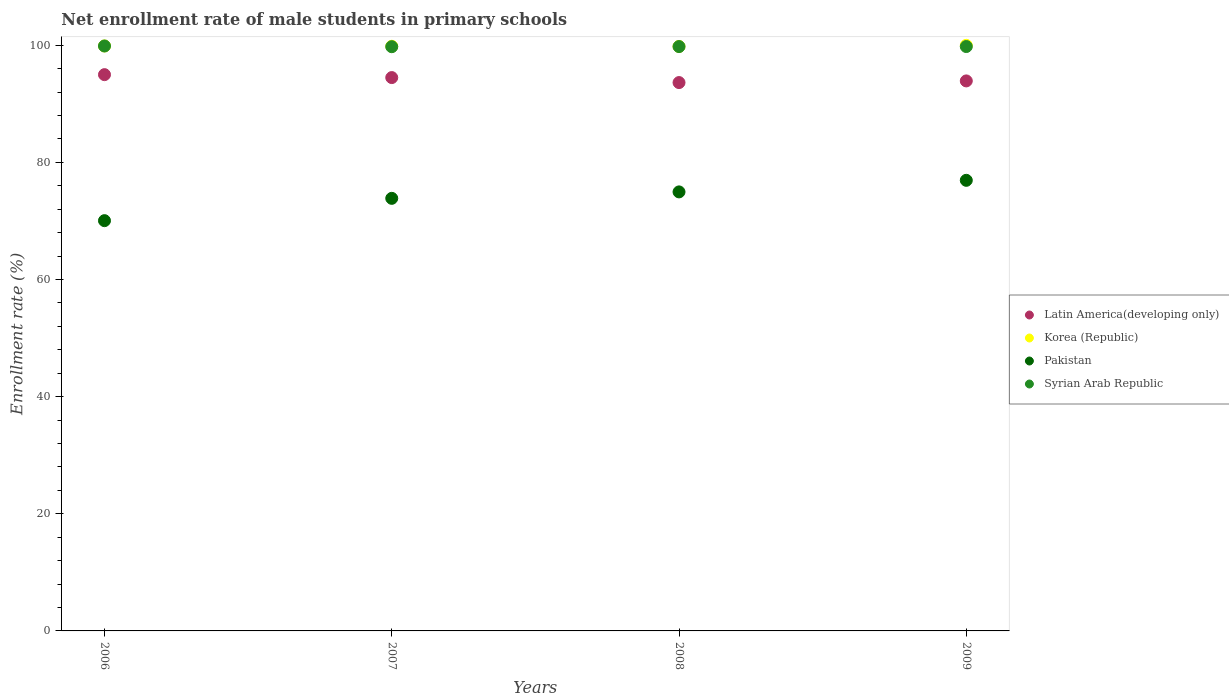How many different coloured dotlines are there?
Your answer should be compact. 4. Is the number of dotlines equal to the number of legend labels?
Make the answer very short. Yes. What is the net enrollment rate of male students in primary schools in Syrian Arab Republic in 2006?
Your answer should be compact. 99.86. Across all years, what is the maximum net enrollment rate of male students in primary schools in Syrian Arab Republic?
Offer a terse response. 99.86. Across all years, what is the minimum net enrollment rate of male students in primary schools in Latin America(developing only)?
Provide a succinct answer. 93.62. In which year was the net enrollment rate of male students in primary schools in Pakistan minimum?
Ensure brevity in your answer.  2006. What is the total net enrollment rate of male students in primary schools in Latin America(developing only) in the graph?
Offer a very short reply. 376.95. What is the difference between the net enrollment rate of male students in primary schools in Pakistan in 2006 and that in 2007?
Provide a succinct answer. -3.81. What is the difference between the net enrollment rate of male students in primary schools in Pakistan in 2006 and the net enrollment rate of male students in primary schools in Syrian Arab Republic in 2009?
Your answer should be compact. -29.73. What is the average net enrollment rate of male students in primary schools in Pakistan per year?
Provide a short and direct response. 73.94. In the year 2006, what is the difference between the net enrollment rate of male students in primary schools in Latin America(developing only) and net enrollment rate of male students in primary schools in Pakistan?
Ensure brevity in your answer.  24.93. In how many years, is the net enrollment rate of male students in primary schools in Korea (Republic) greater than 52 %?
Your answer should be compact. 4. What is the ratio of the net enrollment rate of male students in primary schools in Latin America(developing only) in 2006 to that in 2009?
Keep it short and to the point. 1.01. Is the net enrollment rate of male students in primary schools in Syrian Arab Republic in 2008 less than that in 2009?
Your answer should be compact. Yes. What is the difference between the highest and the second highest net enrollment rate of male students in primary schools in Syrian Arab Republic?
Provide a short and direct response. 0.09. What is the difference between the highest and the lowest net enrollment rate of male students in primary schools in Latin America(developing only)?
Your response must be concise. 1.35. Is the sum of the net enrollment rate of male students in primary schools in Syrian Arab Republic in 2007 and 2009 greater than the maximum net enrollment rate of male students in primary schools in Pakistan across all years?
Make the answer very short. Yes. Is it the case that in every year, the sum of the net enrollment rate of male students in primary schools in Latin America(developing only) and net enrollment rate of male students in primary schools in Pakistan  is greater than the net enrollment rate of male students in primary schools in Syrian Arab Republic?
Ensure brevity in your answer.  Yes. How many years are there in the graph?
Offer a very short reply. 4. What is the difference between two consecutive major ticks on the Y-axis?
Ensure brevity in your answer.  20. Are the values on the major ticks of Y-axis written in scientific E-notation?
Ensure brevity in your answer.  No. Does the graph contain any zero values?
Your answer should be very brief. No. Where does the legend appear in the graph?
Keep it short and to the point. Center right. How many legend labels are there?
Give a very brief answer. 4. How are the legend labels stacked?
Give a very brief answer. Vertical. What is the title of the graph?
Give a very brief answer. Net enrollment rate of male students in primary schools. Does "Niger" appear as one of the legend labels in the graph?
Provide a succinct answer. No. What is the label or title of the Y-axis?
Provide a short and direct response. Enrollment rate (%). What is the Enrollment rate (%) of Latin America(developing only) in 2006?
Your answer should be compact. 94.97. What is the Enrollment rate (%) in Korea (Republic) in 2006?
Your answer should be compact. 99.87. What is the Enrollment rate (%) in Pakistan in 2006?
Offer a very short reply. 70.04. What is the Enrollment rate (%) in Syrian Arab Republic in 2006?
Your answer should be very brief. 99.86. What is the Enrollment rate (%) of Latin America(developing only) in 2007?
Your answer should be very brief. 94.47. What is the Enrollment rate (%) of Korea (Republic) in 2007?
Offer a very short reply. 99.81. What is the Enrollment rate (%) of Pakistan in 2007?
Your answer should be very brief. 73.85. What is the Enrollment rate (%) of Syrian Arab Republic in 2007?
Provide a short and direct response. 99.74. What is the Enrollment rate (%) of Latin America(developing only) in 2008?
Your answer should be very brief. 93.62. What is the Enrollment rate (%) of Korea (Republic) in 2008?
Provide a succinct answer. 99.78. What is the Enrollment rate (%) of Pakistan in 2008?
Make the answer very short. 74.95. What is the Enrollment rate (%) in Syrian Arab Republic in 2008?
Keep it short and to the point. 99.76. What is the Enrollment rate (%) of Latin America(developing only) in 2009?
Make the answer very short. 93.9. What is the Enrollment rate (%) of Korea (Republic) in 2009?
Your answer should be compact. 99.97. What is the Enrollment rate (%) of Pakistan in 2009?
Provide a short and direct response. 76.93. What is the Enrollment rate (%) of Syrian Arab Republic in 2009?
Provide a short and direct response. 99.77. Across all years, what is the maximum Enrollment rate (%) in Latin America(developing only)?
Your answer should be compact. 94.97. Across all years, what is the maximum Enrollment rate (%) in Korea (Republic)?
Keep it short and to the point. 99.97. Across all years, what is the maximum Enrollment rate (%) of Pakistan?
Keep it short and to the point. 76.93. Across all years, what is the maximum Enrollment rate (%) of Syrian Arab Republic?
Your answer should be very brief. 99.86. Across all years, what is the minimum Enrollment rate (%) in Latin America(developing only)?
Your answer should be very brief. 93.62. Across all years, what is the minimum Enrollment rate (%) in Korea (Republic)?
Your answer should be compact. 99.78. Across all years, what is the minimum Enrollment rate (%) of Pakistan?
Offer a very short reply. 70.04. Across all years, what is the minimum Enrollment rate (%) in Syrian Arab Republic?
Make the answer very short. 99.74. What is the total Enrollment rate (%) in Latin America(developing only) in the graph?
Provide a short and direct response. 376.95. What is the total Enrollment rate (%) in Korea (Republic) in the graph?
Give a very brief answer. 399.44. What is the total Enrollment rate (%) of Pakistan in the graph?
Keep it short and to the point. 295.77. What is the total Enrollment rate (%) of Syrian Arab Republic in the graph?
Offer a very short reply. 399.13. What is the difference between the Enrollment rate (%) of Latin America(developing only) in 2006 and that in 2007?
Give a very brief answer. 0.5. What is the difference between the Enrollment rate (%) of Korea (Republic) in 2006 and that in 2007?
Provide a succinct answer. 0.05. What is the difference between the Enrollment rate (%) of Pakistan in 2006 and that in 2007?
Provide a short and direct response. -3.81. What is the difference between the Enrollment rate (%) of Syrian Arab Republic in 2006 and that in 2007?
Offer a very short reply. 0.12. What is the difference between the Enrollment rate (%) in Latin America(developing only) in 2006 and that in 2008?
Offer a terse response. 1.35. What is the difference between the Enrollment rate (%) of Korea (Republic) in 2006 and that in 2008?
Your response must be concise. 0.08. What is the difference between the Enrollment rate (%) of Pakistan in 2006 and that in 2008?
Ensure brevity in your answer.  -4.91. What is the difference between the Enrollment rate (%) in Syrian Arab Republic in 2006 and that in 2008?
Your answer should be compact. 0.1. What is the difference between the Enrollment rate (%) of Latin America(developing only) in 2006 and that in 2009?
Your answer should be compact. 1.07. What is the difference between the Enrollment rate (%) in Korea (Republic) in 2006 and that in 2009?
Ensure brevity in your answer.  -0.11. What is the difference between the Enrollment rate (%) of Pakistan in 2006 and that in 2009?
Provide a succinct answer. -6.89. What is the difference between the Enrollment rate (%) of Syrian Arab Republic in 2006 and that in 2009?
Your response must be concise. 0.09. What is the difference between the Enrollment rate (%) of Latin America(developing only) in 2007 and that in 2008?
Your response must be concise. 0.85. What is the difference between the Enrollment rate (%) of Korea (Republic) in 2007 and that in 2008?
Provide a succinct answer. 0.03. What is the difference between the Enrollment rate (%) of Pakistan in 2007 and that in 2008?
Your answer should be very brief. -1.1. What is the difference between the Enrollment rate (%) in Syrian Arab Republic in 2007 and that in 2008?
Keep it short and to the point. -0.02. What is the difference between the Enrollment rate (%) in Latin America(developing only) in 2007 and that in 2009?
Give a very brief answer. 0.57. What is the difference between the Enrollment rate (%) of Korea (Republic) in 2007 and that in 2009?
Offer a very short reply. -0.16. What is the difference between the Enrollment rate (%) of Pakistan in 2007 and that in 2009?
Your answer should be compact. -3.08. What is the difference between the Enrollment rate (%) of Syrian Arab Republic in 2007 and that in 2009?
Provide a succinct answer. -0.03. What is the difference between the Enrollment rate (%) in Latin America(developing only) in 2008 and that in 2009?
Provide a short and direct response. -0.28. What is the difference between the Enrollment rate (%) in Korea (Republic) in 2008 and that in 2009?
Provide a short and direct response. -0.19. What is the difference between the Enrollment rate (%) in Pakistan in 2008 and that in 2009?
Provide a short and direct response. -1.98. What is the difference between the Enrollment rate (%) of Syrian Arab Republic in 2008 and that in 2009?
Provide a succinct answer. -0. What is the difference between the Enrollment rate (%) of Latin America(developing only) in 2006 and the Enrollment rate (%) of Korea (Republic) in 2007?
Give a very brief answer. -4.84. What is the difference between the Enrollment rate (%) in Latin America(developing only) in 2006 and the Enrollment rate (%) in Pakistan in 2007?
Provide a short and direct response. 21.12. What is the difference between the Enrollment rate (%) of Latin America(developing only) in 2006 and the Enrollment rate (%) of Syrian Arab Republic in 2007?
Your answer should be compact. -4.77. What is the difference between the Enrollment rate (%) of Korea (Republic) in 2006 and the Enrollment rate (%) of Pakistan in 2007?
Make the answer very short. 26.01. What is the difference between the Enrollment rate (%) of Korea (Republic) in 2006 and the Enrollment rate (%) of Syrian Arab Republic in 2007?
Keep it short and to the point. 0.13. What is the difference between the Enrollment rate (%) in Pakistan in 2006 and the Enrollment rate (%) in Syrian Arab Republic in 2007?
Offer a very short reply. -29.7. What is the difference between the Enrollment rate (%) in Latin America(developing only) in 2006 and the Enrollment rate (%) in Korea (Republic) in 2008?
Your answer should be very brief. -4.82. What is the difference between the Enrollment rate (%) of Latin America(developing only) in 2006 and the Enrollment rate (%) of Pakistan in 2008?
Your answer should be compact. 20.02. What is the difference between the Enrollment rate (%) of Latin America(developing only) in 2006 and the Enrollment rate (%) of Syrian Arab Republic in 2008?
Provide a succinct answer. -4.79. What is the difference between the Enrollment rate (%) of Korea (Republic) in 2006 and the Enrollment rate (%) of Pakistan in 2008?
Your answer should be compact. 24.91. What is the difference between the Enrollment rate (%) of Korea (Republic) in 2006 and the Enrollment rate (%) of Syrian Arab Republic in 2008?
Your response must be concise. 0.1. What is the difference between the Enrollment rate (%) in Pakistan in 2006 and the Enrollment rate (%) in Syrian Arab Republic in 2008?
Your answer should be very brief. -29.72. What is the difference between the Enrollment rate (%) in Latin America(developing only) in 2006 and the Enrollment rate (%) in Korea (Republic) in 2009?
Your response must be concise. -5. What is the difference between the Enrollment rate (%) in Latin America(developing only) in 2006 and the Enrollment rate (%) in Pakistan in 2009?
Offer a very short reply. 18.04. What is the difference between the Enrollment rate (%) in Latin America(developing only) in 2006 and the Enrollment rate (%) in Syrian Arab Republic in 2009?
Give a very brief answer. -4.8. What is the difference between the Enrollment rate (%) of Korea (Republic) in 2006 and the Enrollment rate (%) of Pakistan in 2009?
Provide a succinct answer. 22.94. What is the difference between the Enrollment rate (%) in Korea (Republic) in 2006 and the Enrollment rate (%) in Syrian Arab Republic in 2009?
Provide a succinct answer. 0.1. What is the difference between the Enrollment rate (%) in Pakistan in 2006 and the Enrollment rate (%) in Syrian Arab Republic in 2009?
Keep it short and to the point. -29.73. What is the difference between the Enrollment rate (%) of Latin America(developing only) in 2007 and the Enrollment rate (%) of Korea (Republic) in 2008?
Offer a terse response. -5.32. What is the difference between the Enrollment rate (%) in Latin America(developing only) in 2007 and the Enrollment rate (%) in Pakistan in 2008?
Offer a very short reply. 19.52. What is the difference between the Enrollment rate (%) in Latin America(developing only) in 2007 and the Enrollment rate (%) in Syrian Arab Republic in 2008?
Your answer should be very brief. -5.29. What is the difference between the Enrollment rate (%) of Korea (Republic) in 2007 and the Enrollment rate (%) of Pakistan in 2008?
Offer a terse response. 24.86. What is the difference between the Enrollment rate (%) in Korea (Republic) in 2007 and the Enrollment rate (%) in Syrian Arab Republic in 2008?
Offer a terse response. 0.05. What is the difference between the Enrollment rate (%) in Pakistan in 2007 and the Enrollment rate (%) in Syrian Arab Republic in 2008?
Your answer should be very brief. -25.91. What is the difference between the Enrollment rate (%) of Latin America(developing only) in 2007 and the Enrollment rate (%) of Korea (Republic) in 2009?
Provide a succinct answer. -5.5. What is the difference between the Enrollment rate (%) in Latin America(developing only) in 2007 and the Enrollment rate (%) in Pakistan in 2009?
Ensure brevity in your answer.  17.54. What is the difference between the Enrollment rate (%) of Latin America(developing only) in 2007 and the Enrollment rate (%) of Syrian Arab Republic in 2009?
Your answer should be very brief. -5.3. What is the difference between the Enrollment rate (%) in Korea (Republic) in 2007 and the Enrollment rate (%) in Pakistan in 2009?
Ensure brevity in your answer.  22.89. What is the difference between the Enrollment rate (%) of Korea (Republic) in 2007 and the Enrollment rate (%) of Syrian Arab Republic in 2009?
Ensure brevity in your answer.  0.05. What is the difference between the Enrollment rate (%) in Pakistan in 2007 and the Enrollment rate (%) in Syrian Arab Republic in 2009?
Ensure brevity in your answer.  -25.92. What is the difference between the Enrollment rate (%) in Latin America(developing only) in 2008 and the Enrollment rate (%) in Korea (Republic) in 2009?
Keep it short and to the point. -6.36. What is the difference between the Enrollment rate (%) of Latin America(developing only) in 2008 and the Enrollment rate (%) of Pakistan in 2009?
Your answer should be compact. 16.69. What is the difference between the Enrollment rate (%) of Latin America(developing only) in 2008 and the Enrollment rate (%) of Syrian Arab Republic in 2009?
Provide a succinct answer. -6.15. What is the difference between the Enrollment rate (%) in Korea (Republic) in 2008 and the Enrollment rate (%) in Pakistan in 2009?
Offer a very short reply. 22.86. What is the difference between the Enrollment rate (%) in Korea (Republic) in 2008 and the Enrollment rate (%) in Syrian Arab Republic in 2009?
Provide a succinct answer. 0.02. What is the difference between the Enrollment rate (%) in Pakistan in 2008 and the Enrollment rate (%) in Syrian Arab Republic in 2009?
Keep it short and to the point. -24.82. What is the average Enrollment rate (%) of Latin America(developing only) per year?
Your answer should be compact. 94.24. What is the average Enrollment rate (%) in Korea (Republic) per year?
Offer a terse response. 99.86. What is the average Enrollment rate (%) of Pakistan per year?
Give a very brief answer. 73.94. What is the average Enrollment rate (%) in Syrian Arab Republic per year?
Your response must be concise. 99.78. In the year 2006, what is the difference between the Enrollment rate (%) in Latin America(developing only) and Enrollment rate (%) in Korea (Republic)?
Offer a very short reply. -4.9. In the year 2006, what is the difference between the Enrollment rate (%) in Latin America(developing only) and Enrollment rate (%) in Pakistan?
Ensure brevity in your answer.  24.93. In the year 2006, what is the difference between the Enrollment rate (%) of Latin America(developing only) and Enrollment rate (%) of Syrian Arab Republic?
Make the answer very short. -4.89. In the year 2006, what is the difference between the Enrollment rate (%) of Korea (Republic) and Enrollment rate (%) of Pakistan?
Your answer should be compact. 29.82. In the year 2006, what is the difference between the Enrollment rate (%) of Korea (Republic) and Enrollment rate (%) of Syrian Arab Republic?
Ensure brevity in your answer.  0.01. In the year 2006, what is the difference between the Enrollment rate (%) of Pakistan and Enrollment rate (%) of Syrian Arab Republic?
Your response must be concise. -29.82. In the year 2007, what is the difference between the Enrollment rate (%) of Latin America(developing only) and Enrollment rate (%) of Korea (Republic)?
Keep it short and to the point. -5.34. In the year 2007, what is the difference between the Enrollment rate (%) in Latin America(developing only) and Enrollment rate (%) in Pakistan?
Provide a succinct answer. 20.62. In the year 2007, what is the difference between the Enrollment rate (%) of Latin America(developing only) and Enrollment rate (%) of Syrian Arab Republic?
Ensure brevity in your answer.  -5.27. In the year 2007, what is the difference between the Enrollment rate (%) in Korea (Republic) and Enrollment rate (%) in Pakistan?
Offer a very short reply. 25.96. In the year 2007, what is the difference between the Enrollment rate (%) in Korea (Republic) and Enrollment rate (%) in Syrian Arab Republic?
Provide a short and direct response. 0.07. In the year 2007, what is the difference between the Enrollment rate (%) of Pakistan and Enrollment rate (%) of Syrian Arab Republic?
Ensure brevity in your answer.  -25.89. In the year 2008, what is the difference between the Enrollment rate (%) in Latin America(developing only) and Enrollment rate (%) in Korea (Republic)?
Your answer should be very brief. -6.17. In the year 2008, what is the difference between the Enrollment rate (%) in Latin America(developing only) and Enrollment rate (%) in Pakistan?
Make the answer very short. 18.66. In the year 2008, what is the difference between the Enrollment rate (%) in Latin America(developing only) and Enrollment rate (%) in Syrian Arab Republic?
Provide a short and direct response. -6.15. In the year 2008, what is the difference between the Enrollment rate (%) of Korea (Republic) and Enrollment rate (%) of Pakistan?
Provide a short and direct response. 24.83. In the year 2008, what is the difference between the Enrollment rate (%) in Korea (Republic) and Enrollment rate (%) in Syrian Arab Republic?
Offer a terse response. 0.02. In the year 2008, what is the difference between the Enrollment rate (%) in Pakistan and Enrollment rate (%) in Syrian Arab Republic?
Provide a succinct answer. -24.81. In the year 2009, what is the difference between the Enrollment rate (%) in Latin America(developing only) and Enrollment rate (%) in Korea (Republic)?
Offer a terse response. -6.07. In the year 2009, what is the difference between the Enrollment rate (%) in Latin America(developing only) and Enrollment rate (%) in Pakistan?
Your response must be concise. 16.97. In the year 2009, what is the difference between the Enrollment rate (%) of Latin America(developing only) and Enrollment rate (%) of Syrian Arab Republic?
Make the answer very short. -5.87. In the year 2009, what is the difference between the Enrollment rate (%) in Korea (Republic) and Enrollment rate (%) in Pakistan?
Offer a very short reply. 23.04. In the year 2009, what is the difference between the Enrollment rate (%) in Korea (Republic) and Enrollment rate (%) in Syrian Arab Republic?
Provide a short and direct response. 0.2. In the year 2009, what is the difference between the Enrollment rate (%) in Pakistan and Enrollment rate (%) in Syrian Arab Republic?
Your answer should be compact. -22.84. What is the ratio of the Enrollment rate (%) of Pakistan in 2006 to that in 2007?
Ensure brevity in your answer.  0.95. What is the ratio of the Enrollment rate (%) of Latin America(developing only) in 2006 to that in 2008?
Offer a terse response. 1.01. What is the ratio of the Enrollment rate (%) in Pakistan in 2006 to that in 2008?
Give a very brief answer. 0.93. What is the ratio of the Enrollment rate (%) in Syrian Arab Republic in 2006 to that in 2008?
Your answer should be very brief. 1. What is the ratio of the Enrollment rate (%) in Latin America(developing only) in 2006 to that in 2009?
Offer a terse response. 1.01. What is the ratio of the Enrollment rate (%) of Pakistan in 2006 to that in 2009?
Give a very brief answer. 0.91. What is the ratio of the Enrollment rate (%) in Syrian Arab Republic in 2006 to that in 2009?
Your answer should be compact. 1. What is the ratio of the Enrollment rate (%) of Latin America(developing only) in 2007 to that in 2008?
Offer a very short reply. 1.01. What is the ratio of the Enrollment rate (%) of Korea (Republic) in 2007 to that in 2008?
Provide a succinct answer. 1. What is the ratio of the Enrollment rate (%) in Syrian Arab Republic in 2007 to that in 2009?
Your answer should be very brief. 1. What is the ratio of the Enrollment rate (%) of Latin America(developing only) in 2008 to that in 2009?
Provide a short and direct response. 1. What is the ratio of the Enrollment rate (%) of Korea (Republic) in 2008 to that in 2009?
Ensure brevity in your answer.  1. What is the ratio of the Enrollment rate (%) of Pakistan in 2008 to that in 2009?
Provide a succinct answer. 0.97. What is the difference between the highest and the second highest Enrollment rate (%) of Latin America(developing only)?
Ensure brevity in your answer.  0.5. What is the difference between the highest and the second highest Enrollment rate (%) in Korea (Republic)?
Your response must be concise. 0.11. What is the difference between the highest and the second highest Enrollment rate (%) of Pakistan?
Make the answer very short. 1.98. What is the difference between the highest and the second highest Enrollment rate (%) in Syrian Arab Republic?
Make the answer very short. 0.09. What is the difference between the highest and the lowest Enrollment rate (%) in Latin America(developing only)?
Your answer should be very brief. 1.35. What is the difference between the highest and the lowest Enrollment rate (%) of Korea (Republic)?
Offer a terse response. 0.19. What is the difference between the highest and the lowest Enrollment rate (%) in Pakistan?
Your answer should be very brief. 6.89. What is the difference between the highest and the lowest Enrollment rate (%) in Syrian Arab Republic?
Ensure brevity in your answer.  0.12. 